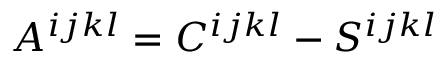<formula> <loc_0><loc_0><loc_500><loc_500>A ^ { i j k l } = C ^ { i j k l } - S ^ { i j k l }</formula> 